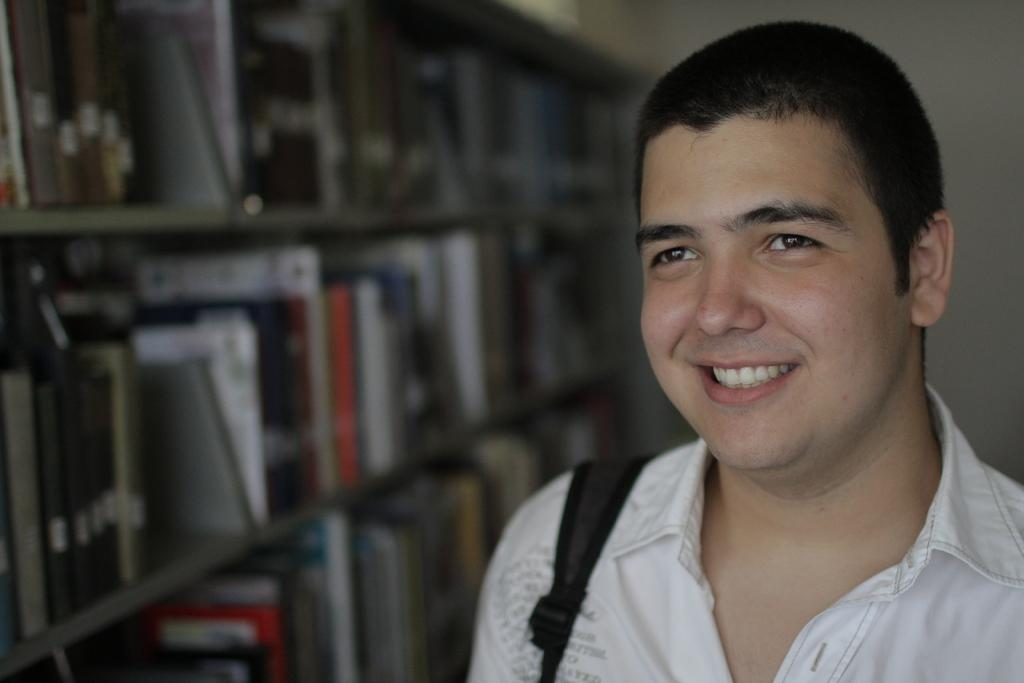What can be seen in the racks in the image? There are books in the racks in the image. Who is present in the image? A man is standing in the image. What is the man's facial expression? The man is smiling. What might the man be carrying on his body? The man appears to be wearing a bag. What type of steel is visible in the image? There is no steel present in the image. Where is the dock located in the image? There is no dock present in the image. 